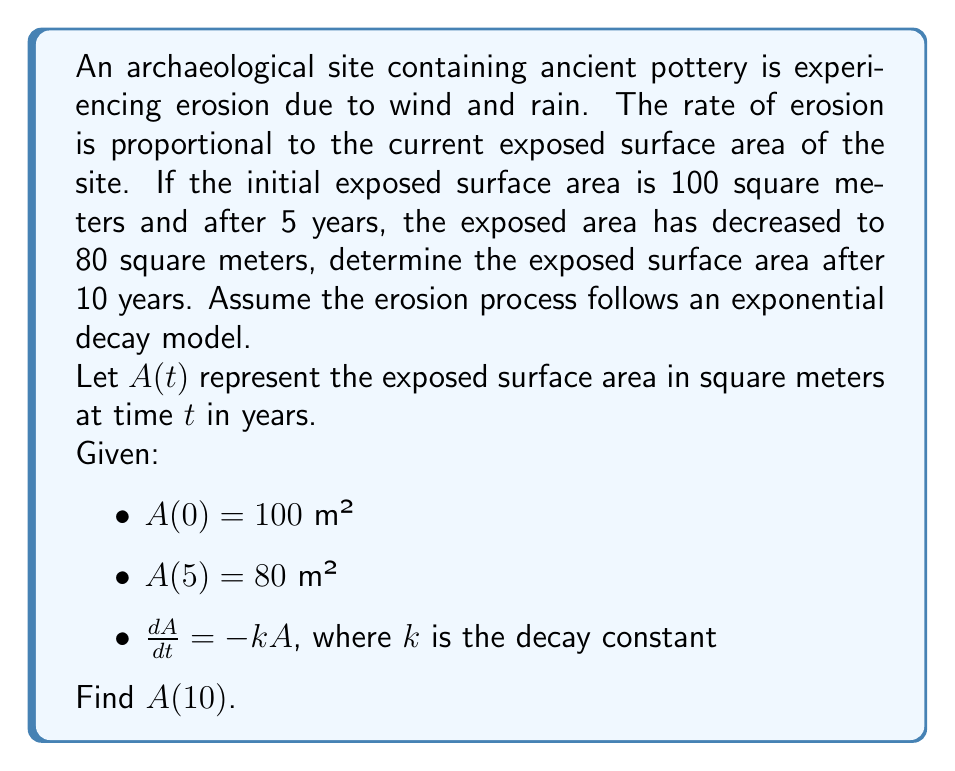Give your solution to this math problem. To solve this problem, we'll use the exponential decay model and the given information to find the decay constant $k$, then use it to calculate the exposed area after 10 years.

1) The general solution for the exponential decay model is:
   $A(t) = A_0e^{-kt}$

   Where $A_0$ is the initial exposed area and $k$ is the decay constant.

2) We know that $A_0 = 100$ m² and $A(5) = 80$ m². Let's use these to find $k$:

   $80 = 100e^{-5k}$

3) Divide both sides by 100:

   $0.8 = e^{-5k}$

4) Take the natural logarithm of both sides:

   $\ln(0.8) = -5k$

5) Solve for $k$:

   $k = -\frac{\ln(0.8)}{5} \approx 0.0446$ year⁻¹

6) Now that we have $k$, we can use the exponential decay formula to find $A(10)$:

   $A(10) = 100e^{-0.0446 \times 10}$

7) Calculate the result:

   $A(10) = 100e^{-0.446} \approx 64.02$ m²

Therefore, after 10 years, the exposed surface area will be approximately 64.02 square meters.
Answer: $A(10) \approx 64.02$ m² 